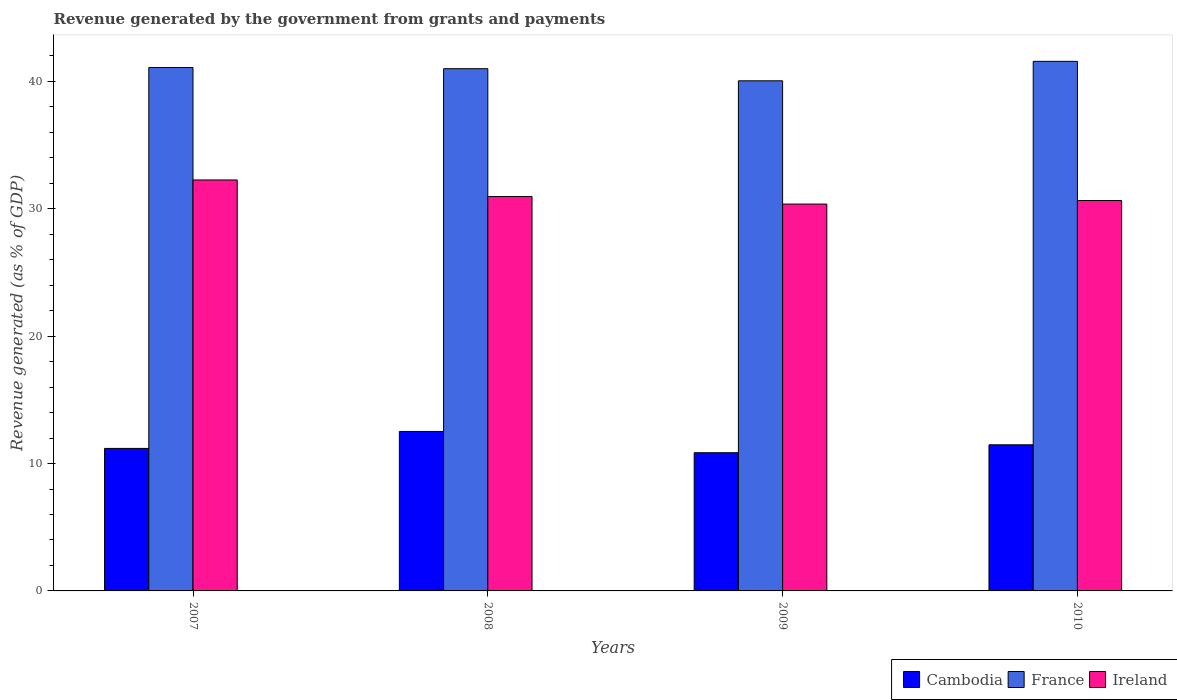How many different coloured bars are there?
Give a very brief answer. 3. Are the number of bars per tick equal to the number of legend labels?
Provide a short and direct response. Yes. How many bars are there on the 3rd tick from the left?
Give a very brief answer. 3. In how many cases, is the number of bars for a given year not equal to the number of legend labels?
Your response must be concise. 0. What is the revenue generated by the government in Ireland in 2008?
Ensure brevity in your answer.  30.96. Across all years, what is the maximum revenue generated by the government in Ireland?
Make the answer very short. 32.26. Across all years, what is the minimum revenue generated by the government in Cambodia?
Provide a short and direct response. 10.85. In which year was the revenue generated by the government in France minimum?
Your answer should be compact. 2009. What is the total revenue generated by the government in Ireland in the graph?
Offer a very short reply. 124.24. What is the difference between the revenue generated by the government in Cambodia in 2007 and that in 2008?
Ensure brevity in your answer.  -1.33. What is the difference between the revenue generated by the government in Cambodia in 2008 and the revenue generated by the government in Ireland in 2010?
Keep it short and to the point. -18.13. What is the average revenue generated by the government in Cambodia per year?
Your answer should be compact. 11.51. In the year 2009, what is the difference between the revenue generated by the government in Cambodia and revenue generated by the government in Ireland?
Your answer should be compact. -19.52. What is the ratio of the revenue generated by the government in Cambodia in 2009 to that in 2010?
Provide a short and direct response. 0.95. What is the difference between the highest and the second highest revenue generated by the government in Cambodia?
Your response must be concise. 1.05. What is the difference between the highest and the lowest revenue generated by the government in France?
Your answer should be very brief. 1.53. In how many years, is the revenue generated by the government in Ireland greater than the average revenue generated by the government in Ireland taken over all years?
Give a very brief answer. 1. What does the 2nd bar from the left in 2008 represents?
Your answer should be compact. France. What does the 1st bar from the right in 2009 represents?
Ensure brevity in your answer.  Ireland. Are all the bars in the graph horizontal?
Give a very brief answer. No. How many years are there in the graph?
Your answer should be very brief. 4. Does the graph contain grids?
Your answer should be very brief. No. How many legend labels are there?
Give a very brief answer. 3. How are the legend labels stacked?
Provide a succinct answer. Horizontal. What is the title of the graph?
Your answer should be very brief. Revenue generated by the government from grants and payments. What is the label or title of the X-axis?
Offer a terse response. Years. What is the label or title of the Y-axis?
Provide a succinct answer. Revenue generated (as % of GDP). What is the Revenue generated (as % of GDP) of Cambodia in 2007?
Offer a very short reply. 11.19. What is the Revenue generated (as % of GDP) in France in 2007?
Offer a very short reply. 41.09. What is the Revenue generated (as % of GDP) in Ireland in 2007?
Offer a very short reply. 32.26. What is the Revenue generated (as % of GDP) of Cambodia in 2008?
Offer a very short reply. 12.52. What is the Revenue generated (as % of GDP) in France in 2008?
Keep it short and to the point. 41. What is the Revenue generated (as % of GDP) of Ireland in 2008?
Give a very brief answer. 30.96. What is the Revenue generated (as % of GDP) of Cambodia in 2009?
Your answer should be compact. 10.85. What is the Revenue generated (as % of GDP) of France in 2009?
Your answer should be very brief. 40.05. What is the Revenue generated (as % of GDP) of Ireland in 2009?
Offer a very short reply. 30.37. What is the Revenue generated (as % of GDP) of Cambodia in 2010?
Keep it short and to the point. 11.47. What is the Revenue generated (as % of GDP) of France in 2010?
Give a very brief answer. 41.57. What is the Revenue generated (as % of GDP) of Ireland in 2010?
Your answer should be very brief. 30.65. Across all years, what is the maximum Revenue generated (as % of GDP) in Cambodia?
Your response must be concise. 12.52. Across all years, what is the maximum Revenue generated (as % of GDP) of France?
Your answer should be very brief. 41.57. Across all years, what is the maximum Revenue generated (as % of GDP) of Ireland?
Provide a short and direct response. 32.26. Across all years, what is the minimum Revenue generated (as % of GDP) in Cambodia?
Provide a short and direct response. 10.85. Across all years, what is the minimum Revenue generated (as % of GDP) in France?
Offer a very short reply. 40.05. Across all years, what is the minimum Revenue generated (as % of GDP) in Ireland?
Offer a very short reply. 30.37. What is the total Revenue generated (as % of GDP) in Cambodia in the graph?
Offer a very short reply. 46.03. What is the total Revenue generated (as % of GDP) of France in the graph?
Provide a succinct answer. 163.71. What is the total Revenue generated (as % of GDP) of Ireland in the graph?
Your answer should be compact. 124.24. What is the difference between the Revenue generated (as % of GDP) of Cambodia in 2007 and that in 2008?
Make the answer very short. -1.33. What is the difference between the Revenue generated (as % of GDP) in France in 2007 and that in 2008?
Keep it short and to the point. 0.09. What is the difference between the Revenue generated (as % of GDP) in Ireland in 2007 and that in 2008?
Keep it short and to the point. 1.3. What is the difference between the Revenue generated (as % of GDP) of Cambodia in 2007 and that in 2009?
Your answer should be very brief. 0.34. What is the difference between the Revenue generated (as % of GDP) of France in 2007 and that in 2009?
Offer a very short reply. 1.04. What is the difference between the Revenue generated (as % of GDP) of Ireland in 2007 and that in 2009?
Your answer should be very brief. 1.89. What is the difference between the Revenue generated (as % of GDP) in Cambodia in 2007 and that in 2010?
Ensure brevity in your answer.  -0.28. What is the difference between the Revenue generated (as % of GDP) in France in 2007 and that in 2010?
Your answer should be very brief. -0.48. What is the difference between the Revenue generated (as % of GDP) in Ireland in 2007 and that in 2010?
Offer a very short reply. 1.62. What is the difference between the Revenue generated (as % of GDP) in Cambodia in 2008 and that in 2009?
Provide a succinct answer. 1.67. What is the difference between the Revenue generated (as % of GDP) of France in 2008 and that in 2009?
Your answer should be compact. 0.95. What is the difference between the Revenue generated (as % of GDP) in Ireland in 2008 and that in 2009?
Provide a short and direct response. 0.59. What is the difference between the Revenue generated (as % of GDP) in Cambodia in 2008 and that in 2010?
Offer a very short reply. 1.05. What is the difference between the Revenue generated (as % of GDP) of France in 2008 and that in 2010?
Ensure brevity in your answer.  -0.58. What is the difference between the Revenue generated (as % of GDP) of Ireland in 2008 and that in 2010?
Your answer should be compact. 0.31. What is the difference between the Revenue generated (as % of GDP) in Cambodia in 2009 and that in 2010?
Ensure brevity in your answer.  -0.62. What is the difference between the Revenue generated (as % of GDP) of France in 2009 and that in 2010?
Provide a short and direct response. -1.53. What is the difference between the Revenue generated (as % of GDP) of Ireland in 2009 and that in 2010?
Offer a very short reply. -0.28. What is the difference between the Revenue generated (as % of GDP) of Cambodia in 2007 and the Revenue generated (as % of GDP) of France in 2008?
Offer a terse response. -29.81. What is the difference between the Revenue generated (as % of GDP) in Cambodia in 2007 and the Revenue generated (as % of GDP) in Ireland in 2008?
Offer a very short reply. -19.77. What is the difference between the Revenue generated (as % of GDP) of France in 2007 and the Revenue generated (as % of GDP) of Ireland in 2008?
Provide a short and direct response. 10.13. What is the difference between the Revenue generated (as % of GDP) in Cambodia in 2007 and the Revenue generated (as % of GDP) in France in 2009?
Your answer should be very brief. -28.86. What is the difference between the Revenue generated (as % of GDP) of Cambodia in 2007 and the Revenue generated (as % of GDP) of Ireland in 2009?
Offer a very short reply. -19.18. What is the difference between the Revenue generated (as % of GDP) of France in 2007 and the Revenue generated (as % of GDP) of Ireland in 2009?
Provide a succinct answer. 10.72. What is the difference between the Revenue generated (as % of GDP) of Cambodia in 2007 and the Revenue generated (as % of GDP) of France in 2010?
Provide a short and direct response. -30.39. What is the difference between the Revenue generated (as % of GDP) of Cambodia in 2007 and the Revenue generated (as % of GDP) of Ireland in 2010?
Ensure brevity in your answer.  -19.46. What is the difference between the Revenue generated (as % of GDP) of France in 2007 and the Revenue generated (as % of GDP) of Ireland in 2010?
Offer a very short reply. 10.44. What is the difference between the Revenue generated (as % of GDP) of Cambodia in 2008 and the Revenue generated (as % of GDP) of France in 2009?
Your answer should be very brief. -27.53. What is the difference between the Revenue generated (as % of GDP) of Cambodia in 2008 and the Revenue generated (as % of GDP) of Ireland in 2009?
Provide a succinct answer. -17.85. What is the difference between the Revenue generated (as % of GDP) in France in 2008 and the Revenue generated (as % of GDP) in Ireland in 2009?
Provide a succinct answer. 10.63. What is the difference between the Revenue generated (as % of GDP) in Cambodia in 2008 and the Revenue generated (as % of GDP) in France in 2010?
Offer a very short reply. -29.05. What is the difference between the Revenue generated (as % of GDP) of Cambodia in 2008 and the Revenue generated (as % of GDP) of Ireland in 2010?
Ensure brevity in your answer.  -18.13. What is the difference between the Revenue generated (as % of GDP) of France in 2008 and the Revenue generated (as % of GDP) of Ireland in 2010?
Keep it short and to the point. 10.35. What is the difference between the Revenue generated (as % of GDP) of Cambodia in 2009 and the Revenue generated (as % of GDP) of France in 2010?
Offer a terse response. -30.72. What is the difference between the Revenue generated (as % of GDP) of Cambodia in 2009 and the Revenue generated (as % of GDP) of Ireland in 2010?
Offer a terse response. -19.8. What is the difference between the Revenue generated (as % of GDP) in France in 2009 and the Revenue generated (as % of GDP) in Ireland in 2010?
Your response must be concise. 9.4. What is the average Revenue generated (as % of GDP) of Cambodia per year?
Provide a short and direct response. 11.51. What is the average Revenue generated (as % of GDP) in France per year?
Provide a short and direct response. 40.93. What is the average Revenue generated (as % of GDP) of Ireland per year?
Offer a very short reply. 31.06. In the year 2007, what is the difference between the Revenue generated (as % of GDP) in Cambodia and Revenue generated (as % of GDP) in France?
Keep it short and to the point. -29.9. In the year 2007, what is the difference between the Revenue generated (as % of GDP) of Cambodia and Revenue generated (as % of GDP) of Ireland?
Keep it short and to the point. -21.07. In the year 2007, what is the difference between the Revenue generated (as % of GDP) in France and Revenue generated (as % of GDP) in Ireland?
Make the answer very short. 8.83. In the year 2008, what is the difference between the Revenue generated (as % of GDP) in Cambodia and Revenue generated (as % of GDP) in France?
Keep it short and to the point. -28.48. In the year 2008, what is the difference between the Revenue generated (as % of GDP) of Cambodia and Revenue generated (as % of GDP) of Ireland?
Offer a terse response. -18.44. In the year 2008, what is the difference between the Revenue generated (as % of GDP) of France and Revenue generated (as % of GDP) of Ireland?
Provide a short and direct response. 10.04. In the year 2009, what is the difference between the Revenue generated (as % of GDP) in Cambodia and Revenue generated (as % of GDP) in France?
Your answer should be compact. -29.2. In the year 2009, what is the difference between the Revenue generated (as % of GDP) in Cambodia and Revenue generated (as % of GDP) in Ireland?
Ensure brevity in your answer.  -19.52. In the year 2009, what is the difference between the Revenue generated (as % of GDP) of France and Revenue generated (as % of GDP) of Ireland?
Offer a very short reply. 9.68. In the year 2010, what is the difference between the Revenue generated (as % of GDP) in Cambodia and Revenue generated (as % of GDP) in France?
Your response must be concise. -30.1. In the year 2010, what is the difference between the Revenue generated (as % of GDP) in Cambodia and Revenue generated (as % of GDP) in Ireland?
Offer a terse response. -19.18. In the year 2010, what is the difference between the Revenue generated (as % of GDP) in France and Revenue generated (as % of GDP) in Ireland?
Your answer should be very brief. 10.93. What is the ratio of the Revenue generated (as % of GDP) in Cambodia in 2007 to that in 2008?
Provide a short and direct response. 0.89. What is the ratio of the Revenue generated (as % of GDP) in France in 2007 to that in 2008?
Provide a succinct answer. 1. What is the ratio of the Revenue generated (as % of GDP) in Ireland in 2007 to that in 2008?
Your answer should be very brief. 1.04. What is the ratio of the Revenue generated (as % of GDP) of Cambodia in 2007 to that in 2009?
Give a very brief answer. 1.03. What is the ratio of the Revenue generated (as % of GDP) in France in 2007 to that in 2009?
Your answer should be very brief. 1.03. What is the ratio of the Revenue generated (as % of GDP) of Ireland in 2007 to that in 2009?
Offer a very short reply. 1.06. What is the ratio of the Revenue generated (as % of GDP) of Cambodia in 2007 to that in 2010?
Your answer should be compact. 0.98. What is the ratio of the Revenue generated (as % of GDP) in France in 2007 to that in 2010?
Your response must be concise. 0.99. What is the ratio of the Revenue generated (as % of GDP) of Ireland in 2007 to that in 2010?
Keep it short and to the point. 1.05. What is the ratio of the Revenue generated (as % of GDP) of Cambodia in 2008 to that in 2009?
Your response must be concise. 1.15. What is the ratio of the Revenue generated (as % of GDP) in France in 2008 to that in 2009?
Your answer should be very brief. 1.02. What is the ratio of the Revenue generated (as % of GDP) in Ireland in 2008 to that in 2009?
Your answer should be compact. 1.02. What is the ratio of the Revenue generated (as % of GDP) in Cambodia in 2008 to that in 2010?
Your answer should be compact. 1.09. What is the ratio of the Revenue generated (as % of GDP) in France in 2008 to that in 2010?
Your answer should be very brief. 0.99. What is the ratio of the Revenue generated (as % of GDP) of Ireland in 2008 to that in 2010?
Your answer should be compact. 1.01. What is the ratio of the Revenue generated (as % of GDP) of Cambodia in 2009 to that in 2010?
Your answer should be compact. 0.95. What is the ratio of the Revenue generated (as % of GDP) of France in 2009 to that in 2010?
Ensure brevity in your answer.  0.96. What is the difference between the highest and the second highest Revenue generated (as % of GDP) of Cambodia?
Keep it short and to the point. 1.05. What is the difference between the highest and the second highest Revenue generated (as % of GDP) of France?
Keep it short and to the point. 0.48. What is the difference between the highest and the second highest Revenue generated (as % of GDP) of Ireland?
Keep it short and to the point. 1.3. What is the difference between the highest and the lowest Revenue generated (as % of GDP) of Cambodia?
Give a very brief answer. 1.67. What is the difference between the highest and the lowest Revenue generated (as % of GDP) of France?
Ensure brevity in your answer.  1.53. What is the difference between the highest and the lowest Revenue generated (as % of GDP) of Ireland?
Provide a short and direct response. 1.89. 